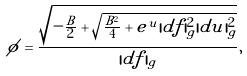<formula> <loc_0><loc_0><loc_500><loc_500>\phi = \frac { \sqrt { - \frac { B } { 2 } + \sqrt { \frac { B ^ { 2 } } { 4 } + e ^ { u } | d f | _ { g } ^ { 2 } | d u | _ { g } ^ { 2 } } } } { | d f | _ { g } } ,</formula> 